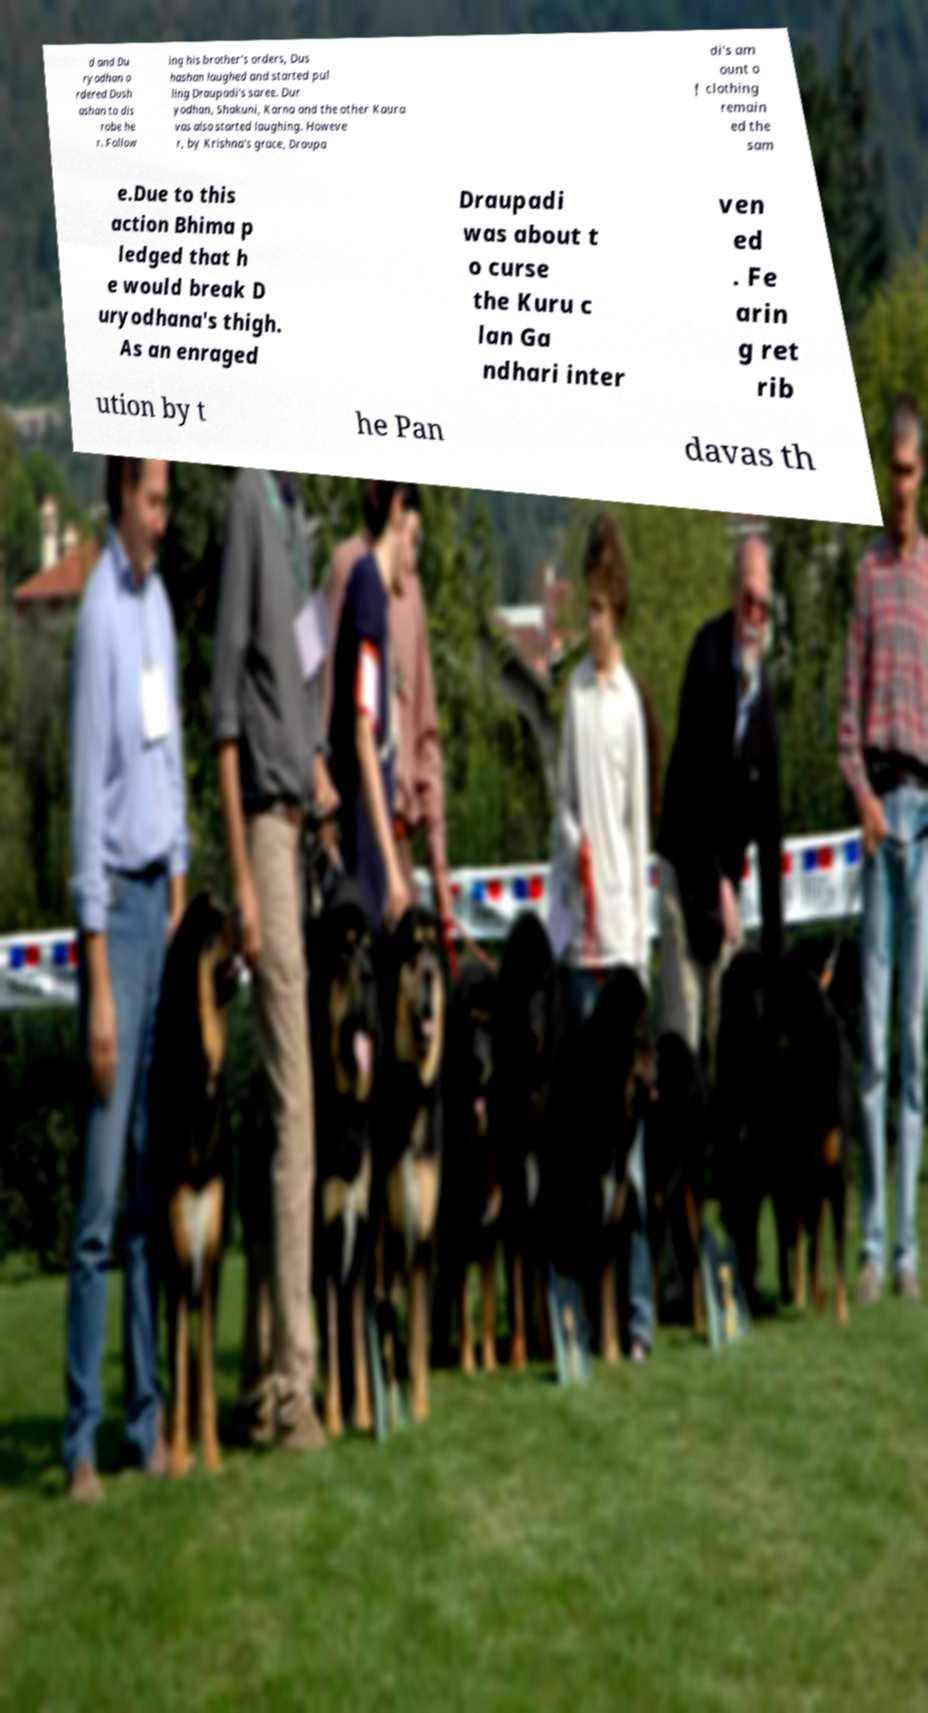There's text embedded in this image that I need extracted. Can you transcribe it verbatim? d and Du ryodhan o rdered Dush ashan to dis robe he r. Follow ing his brother's orders, Dus hashan laughed and started pul ling Draupadi's saree. Dur yodhan, Shakuni, Karna and the other Kaura vas also started laughing. Howeve r, by Krishna's grace, Draupa di's am ount o f clothing remain ed the sam e.Due to this action Bhima p ledged that h e would break D uryodhana's thigh. As an enraged Draupadi was about t o curse the Kuru c lan Ga ndhari inter ven ed . Fe arin g ret rib ution by t he Pan davas th 